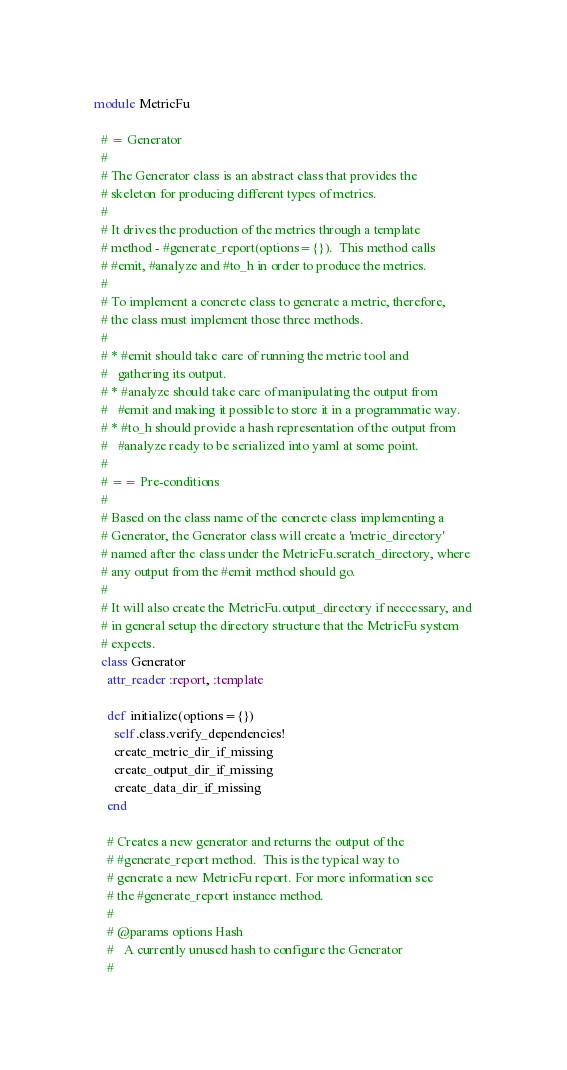<code> <loc_0><loc_0><loc_500><loc_500><_Ruby_>module MetricFu

  # = Generator
  #
  # The Generator class is an abstract class that provides the 
  # skeleton for producing different types of metrics.
  #
  # It drives the production of the metrics through a template 
  # method - #generate_report(options={}).  This method calls
  # #emit, #analyze and #to_h in order to produce the metrics.
  #
  # To implement a concrete class to generate a metric, therefore,
  # the class must implement those three methods. 
  #
  # * #emit should take care of running the metric tool and 
  #   gathering its output.  
  # * #analyze should take care of manipulating the output from
  #   #emit and making it possible to store it in a programmatic way.
  # * #to_h should provide a hash representation of the output from
  #   #analyze ready to be serialized into yaml at some point.
  #
  # == Pre-conditions
  #
  # Based on the class name of the concrete class implementing a
  # Generator, the Generator class will create a 'metric_directory'
  # named after the class under the MetricFu.scratch_directory, where
  # any output from the #emit method should go.
  #
  # It will also create the MetricFu.output_directory if neccessary, and
  # in general setup the directory structure that the MetricFu system
  # expects.
  class Generator
    attr_reader :report, :template

    def initialize(options={})
      self.class.verify_dependencies!
      create_metric_dir_if_missing
      create_output_dir_if_missing
      create_data_dir_if_missing
    end
    
    # Creates a new generator and returns the output of the 
    # #generate_report method.  This is the typical way to 
    # generate a new MetricFu report. For more information see
    # the #generate_report instance method.
    #
    # @params options Hash
    #   A currently unused hash to configure the Generator
    #</code> 